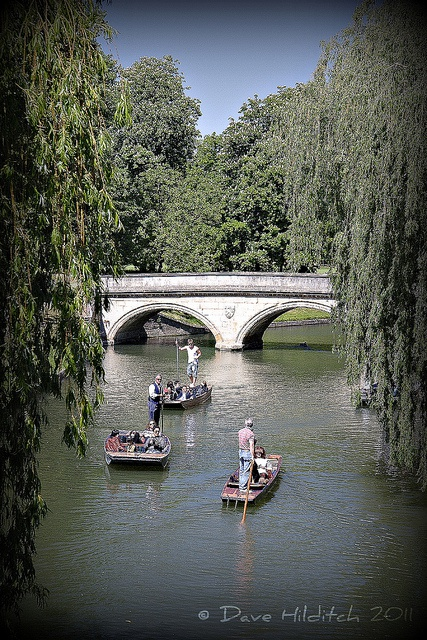Describe the objects in this image and their specific colors. I can see boat in black, gray, darkgray, and lightgray tones, boat in black, gray, darkgray, and white tones, people in black, lavender, darkgray, and gray tones, people in black, white, darkgray, and gray tones, and people in black, white, gray, and darkgray tones in this image. 